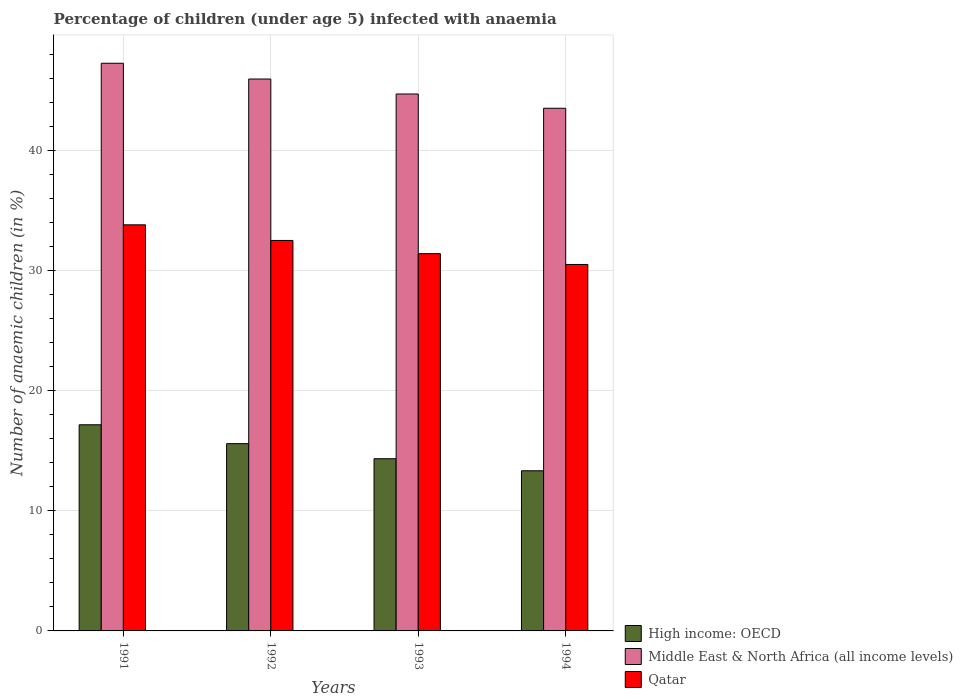How many different coloured bars are there?
Your response must be concise. 3. How many groups of bars are there?
Give a very brief answer. 4. How many bars are there on the 4th tick from the left?
Your answer should be compact. 3. What is the label of the 2nd group of bars from the left?
Your response must be concise. 1992. In how many cases, is the number of bars for a given year not equal to the number of legend labels?
Ensure brevity in your answer.  0. What is the percentage of children infected with anaemia in in Middle East & North Africa (all income levels) in 1994?
Your answer should be very brief. 43.5. Across all years, what is the maximum percentage of children infected with anaemia in in Middle East & North Africa (all income levels)?
Ensure brevity in your answer.  47.25. Across all years, what is the minimum percentage of children infected with anaemia in in Qatar?
Offer a very short reply. 30.5. In which year was the percentage of children infected with anaemia in in Qatar maximum?
Your answer should be very brief. 1991. In which year was the percentage of children infected with anaemia in in High income: OECD minimum?
Offer a very short reply. 1994. What is the total percentage of children infected with anaemia in in Qatar in the graph?
Make the answer very short. 128.2. What is the difference between the percentage of children infected with anaemia in in Qatar in 1991 and that in 1994?
Keep it short and to the point. 3.3. What is the difference between the percentage of children infected with anaemia in in High income: OECD in 1992 and the percentage of children infected with anaemia in in Middle East & North Africa (all income levels) in 1993?
Make the answer very short. -29.1. What is the average percentage of children infected with anaemia in in Qatar per year?
Provide a succinct answer. 32.05. In the year 1991, what is the difference between the percentage of children infected with anaemia in in High income: OECD and percentage of children infected with anaemia in in Middle East & North Africa (all income levels)?
Your response must be concise. -30.09. What is the ratio of the percentage of children infected with anaemia in in Qatar in 1991 to that in 1994?
Provide a succinct answer. 1.11. Is the difference between the percentage of children infected with anaemia in in High income: OECD in 1991 and 1993 greater than the difference between the percentage of children infected with anaemia in in Middle East & North Africa (all income levels) in 1991 and 1993?
Your response must be concise. Yes. What is the difference between the highest and the second highest percentage of children infected with anaemia in in High income: OECD?
Provide a succinct answer. 1.57. What is the difference between the highest and the lowest percentage of children infected with anaemia in in Qatar?
Ensure brevity in your answer.  3.3. In how many years, is the percentage of children infected with anaemia in in Middle East & North Africa (all income levels) greater than the average percentage of children infected with anaemia in in Middle East & North Africa (all income levels) taken over all years?
Provide a short and direct response. 2. What does the 3rd bar from the left in 1992 represents?
Your response must be concise. Qatar. What does the 3rd bar from the right in 1992 represents?
Provide a succinct answer. High income: OECD. Is it the case that in every year, the sum of the percentage of children infected with anaemia in in High income: OECD and percentage of children infected with anaemia in in Qatar is greater than the percentage of children infected with anaemia in in Middle East & North Africa (all income levels)?
Your response must be concise. Yes. How many bars are there?
Your answer should be compact. 12. Does the graph contain grids?
Keep it short and to the point. Yes. Where does the legend appear in the graph?
Your answer should be very brief. Bottom right. How many legend labels are there?
Your answer should be very brief. 3. How are the legend labels stacked?
Give a very brief answer. Vertical. What is the title of the graph?
Your answer should be compact. Percentage of children (under age 5) infected with anaemia. What is the label or title of the X-axis?
Provide a short and direct response. Years. What is the label or title of the Y-axis?
Your response must be concise. Number of anaemic children (in %). What is the Number of anaemic children (in %) of High income: OECD in 1991?
Your answer should be very brief. 17.16. What is the Number of anaemic children (in %) in Middle East & North Africa (all income levels) in 1991?
Your response must be concise. 47.25. What is the Number of anaemic children (in %) of Qatar in 1991?
Keep it short and to the point. 33.8. What is the Number of anaemic children (in %) of High income: OECD in 1992?
Make the answer very short. 15.59. What is the Number of anaemic children (in %) of Middle East & North Africa (all income levels) in 1992?
Offer a terse response. 45.93. What is the Number of anaemic children (in %) in Qatar in 1992?
Make the answer very short. 32.5. What is the Number of anaemic children (in %) of High income: OECD in 1993?
Ensure brevity in your answer.  14.33. What is the Number of anaemic children (in %) of Middle East & North Africa (all income levels) in 1993?
Keep it short and to the point. 44.69. What is the Number of anaemic children (in %) of Qatar in 1993?
Keep it short and to the point. 31.4. What is the Number of anaemic children (in %) of High income: OECD in 1994?
Your answer should be compact. 13.33. What is the Number of anaemic children (in %) in Middle East & North Africa (all income levels) in 1994?
Offer a terse response. 43.5. What is the Number of anaemic children (in %) in Qatar in 1994?
Keep it short and to the point. 30.5. Across all years, what is the maximum Number of anaemic children (in %) in High income: OECD?
Your answer should be very brief. 17.16. Across all years, what is the maximum Number of anaemic children (in %) in Middle East & North Africa (all income levels)?
Your answer should be very brief. 47.25. Across all years, what is the maximum Number of anaemic children (in %) of Qatar?
Your answer should be compact. 33.8. Across all years, what is the minimum Number of anaemic children (in %) in High income: OECD?
Ensure brevity in your answer.  13.33. Across all years, what is the minimum Number of anaemic children (in %) in Middle East & North Africa (all income levels)?
Provide a short and direct response. 43.5. Across all years, what is the minimum Number of anaemic children (in %) of Qatar?
Provide a short and direct response. 30.5. What is the total Number of anaemic children (in %) in High income: OECD in the graph?
Offer a very short reply. 60.4. What is the total Number of anaemic children (in %) of Middle East & North Africa (all income levels) in the graph?
Provide a short and direct response. 181.37. What is the total Number of anaemic children (in %) in Qatar in the graph?
Your answer should be very brief. 128.2. What is the difference between the Number of anaemic children (in %) in High income: OECD in 1991 and that in 1992?
Offer a terse response. 1.57. What is the difference between the Number of anaemic children (in %) of Middle East & North Africa (all income levels) in 1991 and that in 1992?
Offer a terse response. 1.31. What is the difference between the Number of anaemic children (in %) in Qatar in 1991 and that in 1992?
Ensure brevity in your answer.  1.3. What is the difference between the Number of anaemic children (in %) in High income: OECD in 1991 and that in 1993?
Your response must be concise. 2.83. What is the difference between the Number of anaemic children (in %) of Middle East & North Africa (all income levels) in 1991 and that in 1993?
Your answer should be compact. 2.56. What is the difference between the Number of anaemic children (in %) of High income: OECD in 1991 and that in 1994?
Give a very brief answer. 3.83. What is the difference between the Number of anaemic children (in %) of Middle East & North Africa (all income levels) in 1991 and that in 1994?
Offer a terse response. 3.75. What is the difference between the Number of anaemic children (in %) in Qatar in 1991 and that in 1994?
Offer a very short reply. 3.3. What is the difference between the Number of anaemic children (in %) in High income: OECD in 1992 and that in 1993?
Make the answer very short. 1.25. What is the difference between the Number of anaemic children (in %) in Middle East & North Africa (all income levels) in 1992 and that in 1993?
Ensure brevity in your answer.  1.25. What is the difference between the Number of anaemic children (in %) of Qatar in 1992 and that in 1993?
Give a very brief answer. 1.1. What is the difference between the Number of anaemic children (in %) in High income: OECD in 1992 and that in 1994?
Ensure brevity in your answer.  2.26. What is the difference between the Number of anaemic children (in %) of Middle East & North Africa (all income levels) in 1992 and that in 1994?
Provide a short and direct response. 2.43. What is the difference between the Number of anaemic children (in %) in Qatar in 1992 and that in 1994?
Make the answer very short. 2. What is the difference between the Number of anaemic children (in %) in Middle East & North Africa (all income levels) in 1993 and that in 1994?
Make the answer very short. 1.19. What is the difference between the Number of anaemic children (in %) of High income: OECD in 1991 and the Number of anaemic children (in %) of Middle East & North Africa (all income levels) in 1992?
Make the answer very short. -28.78. What is the difference between the Number of anaemic children (in %) in High income: OECD in 1991 and the Number of anaemic children (in %) in Qatar in 1992?
Your response must be concise. -15.34. What is the difference between the Number of anaemic children (in %) of Middle East & North Africa (all income levels) in 1991 and the Number of anaemic children (in %) of Qatar in 1992?
Your answer should be compact. 14.75. What is the difference between the Number of anaemic children (in %) of High income: OECD in 1991 and the Number of anaemic children (in %) of Middle East & North Africa (all income levels) in 1993?
Your answer should be compact. -27.53. What is the difference between the Number of anaemic children (in %) of High income: OECD in 1991 and the Number of anaemic children (in %) of Qatar in 1993?
Your answer should be very brief. -14.24. What is the difference between the Number of anaemic children (in %) of Middle East & North Africa (all income levels) in 1991 and the Number of anaemic children (in %) of Qatar in 1993?
Offer a terse response. 15.85. What is the difference between the Number of anaemic children (in %) of High income: OECD in 1991 and the Number of anaemic children (in %) of Middle East & North Africa (all income levels) in 1994?
Provide a short and direct response. -26.34. What is the difference between the Number of anaemic children (in %) in High income: OECD in 1991 and the Number of anaemic children (in %) in Qatar in 1994?
Ensure brevity in your answer.  -13.34. What is the difference between the Number of anaemic children (in %) in Middle East & North Africa (all income levels) in 1991 and the Number of anaemic children (in %) in Qatar in 1994?
Offer a very short reply. 16.75. What is the difference between the Number of anaemic children (in %) of High income: OECD in 1992 and the Number of anaemic children (in %) of Middle East & North Africa (all income levels) in 1993?
Your response must be concise. -29.1. What is the difference between the Number of anaemic children (in %) of High income: OECD in 1992 and the Number of anaemic children (in %) of Qatar in 1993?
Your answer should be very brief. -15.81. What is the difference between the Number of anaemic children (in %) of Middle East & North Africa (all income levels) in 1992 and the Number of anaemic children (in %) of Qatar in 1993?
Provide a short and direct response. 14.53. What is the difference between the Number of anaemic children (in %) in High income: OECD in 1992 and the Number of anaemic children (in %) in Middle East & North Africa (all income levels) in 1994?
Ensure brevity in your answer.  -27.91. What is the difference between the Number of anaemic children (in %) in High income: OECD in 1992 and the Number of anaemic children (in %) in Qatar in 1994?
Offer a terse response. -14.91. What is the difference between the Number of anaemic children (in %) of Middle East & North Africa (all income levels) in 1992 and the Number of anaemic children (in %) of Qatar in 1994?
Offer a terse response. 15.43. What is the difference between the Number of anaemic children (in %) in High income: OECD in 1993 and the Number of anaemic children (in %) in Middle East & North Africa (all income levels) in 1994?
Ensure brevity in your answer.  -29.17. What is the difference between the Number of anaemic children (in %) in High income: OECD in 1993 and the Number of anaemic children (in %) in Qatar in 1994?
Give a very brief answer. -16.17. What is the difference between the Number of anaemic children (in %) in Middle East & North Africa (all income levels) in 1993 and the Number of anaemic children (in %) in Qatar in 1994?
Make the answer very short. 14.19. What is the average Number of anaemic children (in %) in High income: OECD per year?
Make the answer very short. 15.1. What is the average Number of anaemic children (in %) in Middle East & North Africa (all income levels) per year?
Provide a short and direct response. 45.34. What is the average Number of anaemic children (in %) in Qatar per year?
Your response must be concise. 32.05. In the year 1991, what is the difference between the Number of anaemic children (in %) in High income: OECD and Number of anaemic children (in %) in Middle East & North Africa (all income levels)?
Provide a short and direct response. -30.09. In the year 1991, what is the difference between the Number of anaemic children (in %) of High income: OECD and Number of anaemic children (in %) of Qatar?
Offer a terse response. -16.64. In the year 1991, what is the difference between the Number of anaemic children (in %) of Middle East & North Africa (all income levels) and Number of anaemic children (in %) of Qatar?
Offer a terse response. 13.45. In the year 1992, what is the difference between the Number of anaemic children (in %) of High income: OECD and Number of anaemic children (in %) of Middle East & North Africa (all income levels)?
Offer a very short reply. -30.35. In the year 1992, what is the difference between the Number of anaemic children (in %) in High income: OECD and Number of anaemic children (in %) in Qatar?
Make the answer very short. -16.91. In the year 1992, what is the difference between the Number of anaemic children (in %) in Middle East & North Africa (all income levels) and Number of anaemic children (in %) in Qatar?
Give a very brief answer. 13.43. In the year 1993, what is the difference between the Number of anaemic children (in %) in High income: OECD and Number of anaemic children (in %) in Middle East & North Africa (all income levels)?
Provide a short and direct response. -30.36. In the year 1993, what is the difference between the Number of anaemic children (in %) in High income: OECD and Number of anaemic children (in %) in Qatar?
Your answer should be very brief. -17.07. In the year 1993, what is the difference between the Number of anaemic children (in %) of Middle East & North Africa (all income levels) and Number of anaemic children (in %) of Qatar?
Offer a very short reply. 13.29. In the year 1994, what is the difference between the Number of anaemic children (in %) of High income: OECD and Number of anaemic children (in %) of Middle East & North Africa (all income levels)?
Offer a terse response. -30.17. In the year 1994, what is the difference between the Number of anaemic children (in %) in High income: OECD and Number of anaemic children (in %) in Qatar?
Make the answer very short. -17.17. In the year 1994, what is the difference between the Number of anaemic children (in %) of Middle East & North Africa (all income levels) and Number of anaemic children (in %) of Qatar?
Offer a terse response. 13. What is the ratio of the Number of anaemic children (in %) in High income: OECD in 1991 to that in 1992?
Your answer should be compact. 1.1. What is the ratio of the Number of anaemic children (in %) of Middle East & North Africa (all income levels) in 1991 to that in 1992?
Give a very brief answer. 1.03. What is the ratio of the Number of anaemic children (in %) of High income: OECD in 1991 to that in 1993?
Offer a very short reply. 1.2. What is the ratio of the Number of anaemic children (in %) of Middle East & North Africa (all income levels) in 1991 to that in 1993?
Provide a succinct answer. 1.06. What is the ratio of the Number of anaemic children (in %) in Qatar in 1991 to that in 1993?
Offer a very short reply. 1.08. What is the ratio of the Number of anaemic children (in %) of High income: OECD in 1991 to that in 1994?
Provide a succinct answer. 1.29. What is the ratio of the Number of anaemic children (in %) in Middle East & North Africa (all income levels) in 1991 to that in 1994?
Your answer should be very brief. 1.09. What is the ratio of the Number of anaemic children (in %) of Qatar in 1991 to that in 1994?
Your response must be concise. 1.11. What is the ratio of the Number of anaemic children (in %) in High income: OECD in 1992 to that in 1993?
Provide a short and direct response. 1.09. What is the ratio of the Number of anaemic children (in %) of Middle East & North Africa (all income levels) in 1992 to that in 1993?
Your answer should be compact. 1.03. What is the ratio of the Number of anaemic children (in %) of Qatar in 1992 to that in 1993?
Provide a short and direct response. 1.03. What is the ratio of the Number of anaemic children (in %) of High income: OECD in 1992 to that in 1994?
Offer a terse response. 1.17. What is the ratio of the Number of anaemic children (in %) in Middle East & North Africa (all income levels) in 1992 to that in 1994?
Your response must be concise. 1.06. What is the ratio of the Number of anaemic children (in %) of Qatar in 1992 to that in 1994?
Keep it short and to the point. 1.07. What is the ratio of the Number of anaemic children (in %) in High income: OECD in 1993 to that in 1994?
Offer a very short reply. 1.08. What is the ratio of the Number of anaemic children (in %) in Middle East & North Africa (all income levels) in 1993 to that in 1994?
Your response must be concise. 1.03. What is the ratio of the Number of anaemic children (in %) in Qatar in 1993 to that in 1994?
Provide a short and direct response. 1.03. What is the difference between the highest and the second highest Number of anaemic children (in %) in High income: OECD?
Ensure brevity in your answer.  1.57. What is the difference between the highest and the second highest Number of anaemic children (in %) in Middle East & North Africa (all income levels)?
Your answer should be very brief. 1.31. What is the difference between the highest and the second highest Number of anaemic children (in %) in Qatar?
Ensure brevity in your answer.  1.3. What is the difference between the highest and the lowest Number of anaemic children (in %) of High income: OECD?
Provide a short and direct response. 3.83. What is the difference between the highest and the lowest Number of anaemic children (in %) of Middle East & North Africa (all income levels)?
Your answer should be compact. 3.75. 